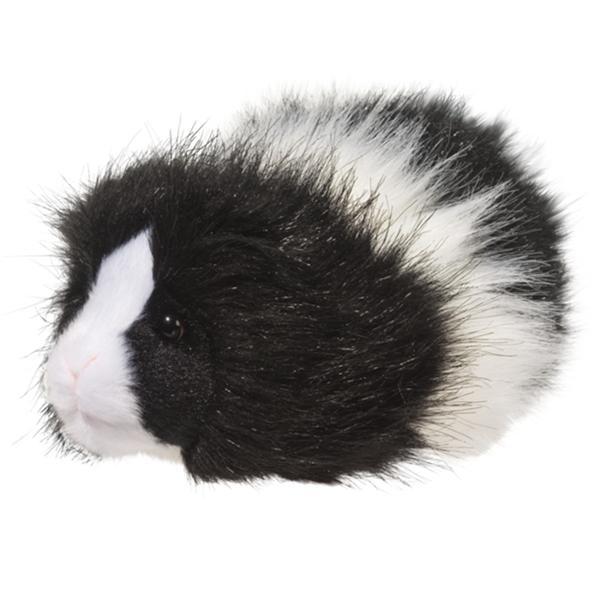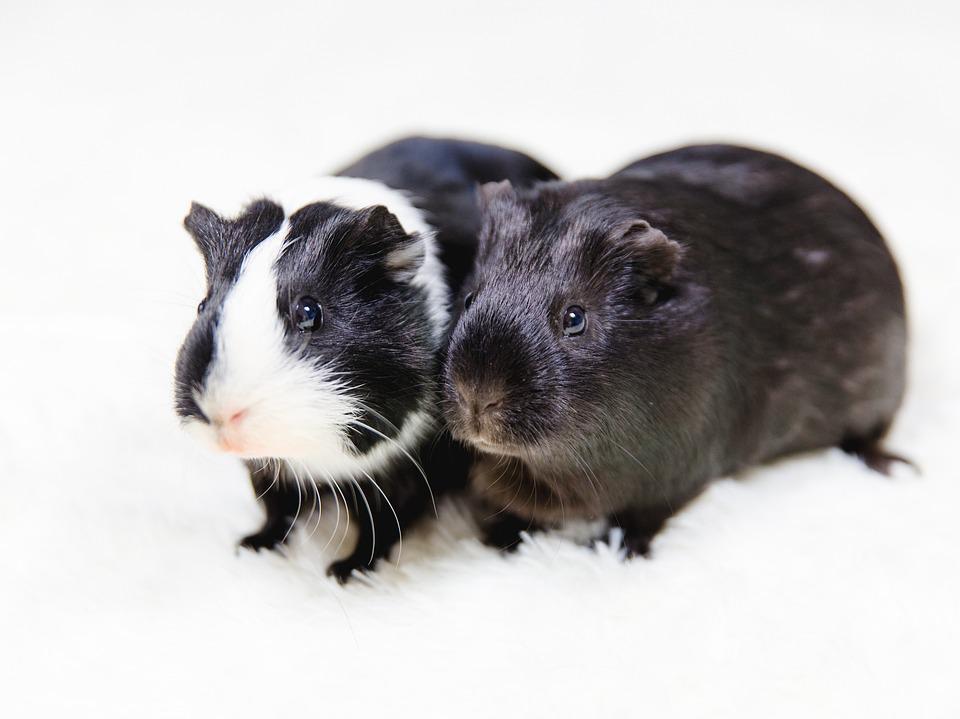The first image is the image on the left, the second image is the image on the right. Given the left and right images, does the statement "There is at least two rodents in the right image." hold true? Answer yes or no. Yes. The first image is the image on the left, the second image is the image on the right. For the images shown, is this caption "There are exactly two guinea pigs in total." true? Answer yes or no. No. 